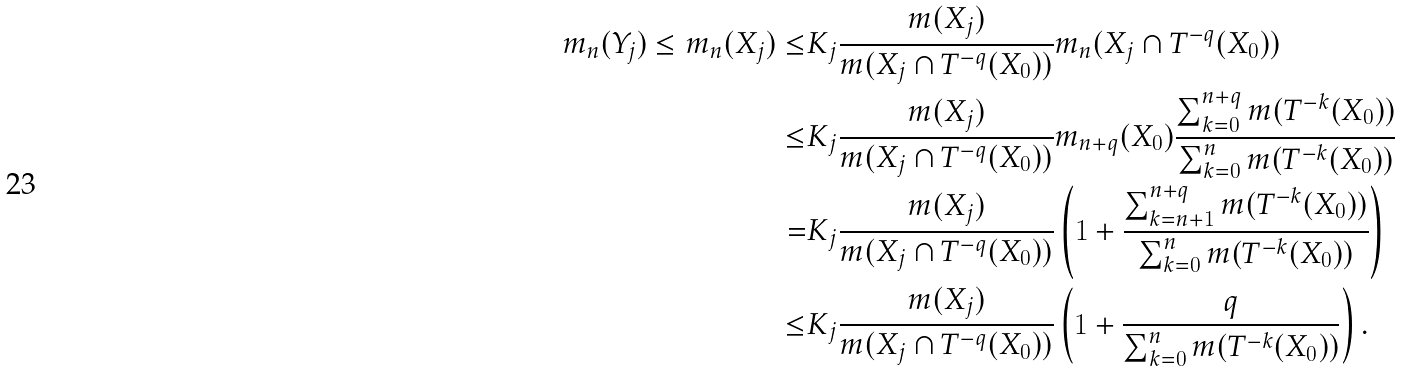<formula> <loc_0><loc_0><loc_500><loc_500>m _ { n } ( Y _ { j } ) \leq m _ { n } ( X _ { j } ) \leq & K _ { j } \frac { m ( X _ { j } ) } { m ( X _ { j } \cap T ^ { - q } ( X _ { 0 } ) ) } m _ { n } ( X _ { j } \cap T ^ { - q } ( X _ { 0 } ) ) \\ \leq & K _ { j } \frac { m ( X _ { j } ) } { m ( X _ { j } \cap T ^ { - q } ( X _ { 0 } ) ) } m _ { n + q } ( X _ { 0 } ) \frac { \sum _ { k = 0 } ^ { n + q } m ( T ^ { - k } ( X _ { 0 } ) ) } { \sum _ { k = 0 } ^ { n } m ( T ^ { - k } ( X _ { 0 } ) ) } \\ = & K _ { j } \frac { m ( X _ { j } ) } { m ( X _ { j } \cap T ^ { - q } ( X _ { 0 } ) ) } \left ( 1 + \frac { \sum _ { k = n + 1 } ^ { n + q } m ( T ^ { - k } ( X _ { 0 } ) ) } { \sum _ { k = 0 } ^ { n } m ( T ^ { - k } ( X _ { 0 } ) ) } \right ) \\ \leq & K _ { j } \frac { m ( X _ { j } ) } { m ( X _ { j } \cap T ^ { - q } ( X _ { 0 } ) ) } \left ( 1 + \frac { q } { \sum _ { k = 0 } ^ { n } m ( T ^ { - k } ( X _ { 0 } ) ) } \right ) .</formula> 